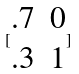Convert formula to latex. <formula><loc_0><loc_0><loc_500><loc_500>[ \begin{matrix} . 7 & 0 \\ . 3 & 1 \end{matrix} ]</formula> 